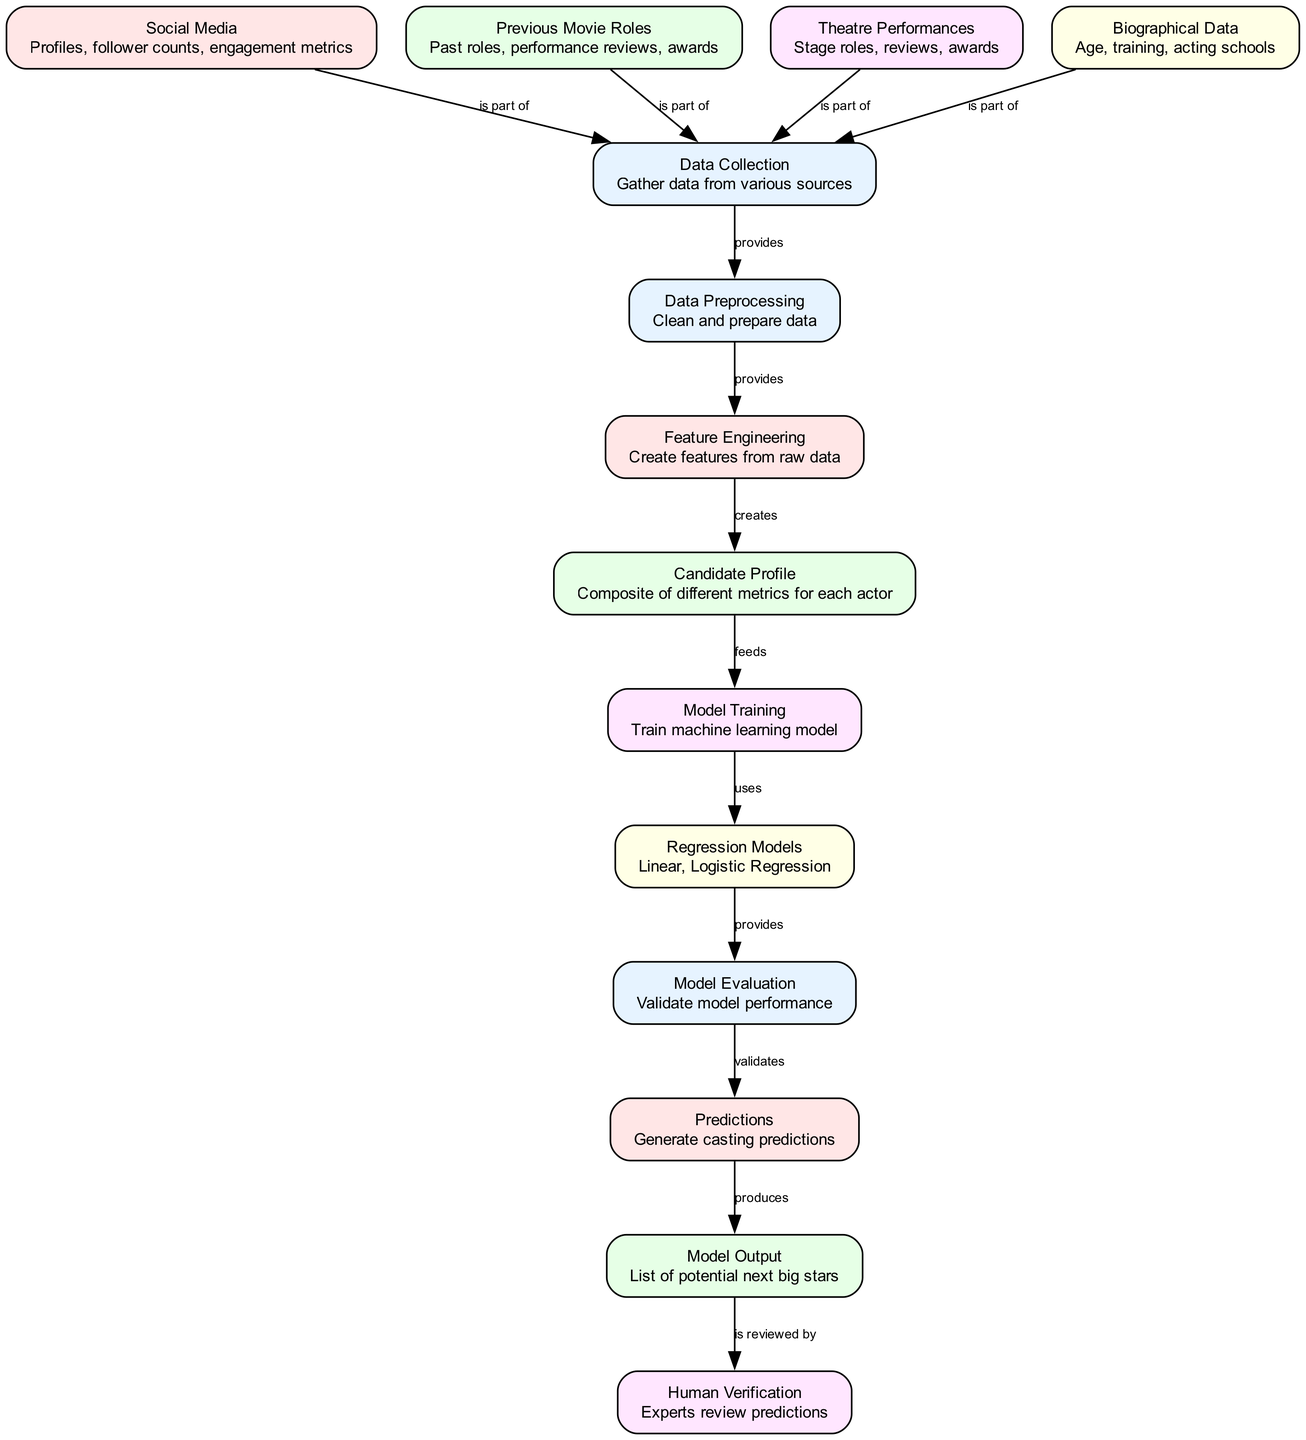What is the first step in the diagram? The first step shown in the diagram is "Data Collection," which indicates that data must be gathered from various sources before any further processing can occur.
Answer: Data Collection How many nodes are present in the diagram? By counting the nodes listed in the diagram, I find there are a total of 13 distinct nodes representing different parts of the casting prediction process.
Answer: 13 What data source is part of the "Data Collection"? "Social Media" is explicitly mentioned as one of the sources contributing to "Data Collection," indicating that profiles, follower counts, and engagement metrics are collected.
Answer: Social Media What follows "Data Preprocessing" in the diagram? The diagram indicates that "Feature Engineering" follows "Data Preprocessing," meaning the cleaned and prepared data is then used to create features for further analysis.
Answer: Feature Engineering Which node produces "Model Output"? The node labeled "Predictions" produces "Model Output," as indicated in the diagram, showing that generated predictions lead to the final output of potential next big stars.
Answer: Model Output How many edges are connected to "Model Training"? "Model Training" has two edges connected to it, one from "Candidate Profile" and one leading to "Regression Models," indicating its input and output connections.
Answer: 2 What role do experts have in the process? Experts in the diagram are involved in "Human Verification," where the predictions generated are reviewed to ensure quality and relevance.
Answer: Human Verification What type of models are used for training? The diagram specifies "Regression Models" are used during the "Model Training" phase, indicating the type of machine learning models applied to the data.
Answer: Regression Models What step validates model performance? The step that validates model performance in the process is labeled "Model Evaluation," which assesses how well the machine learning model is performing based on the input data.
Answer: Model Evaluation 